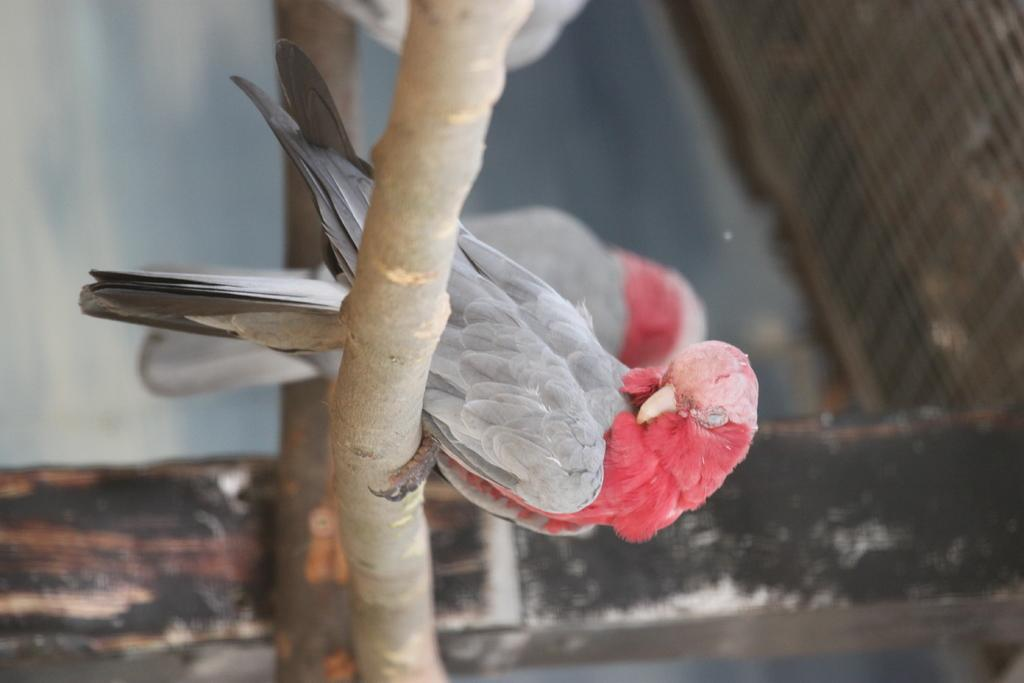What type of animals can be seen in the image? There are birds in the image. Where are the birds located? The birds are on the barks of trees. Can you describe the background of the image? The background of the image is not clear. What type of mask is the bird wearing in the image? There is no mask present on the birds in the image. What type of magic is the bird performing in the image? There is no magic or any indication of magical activity in the image. 